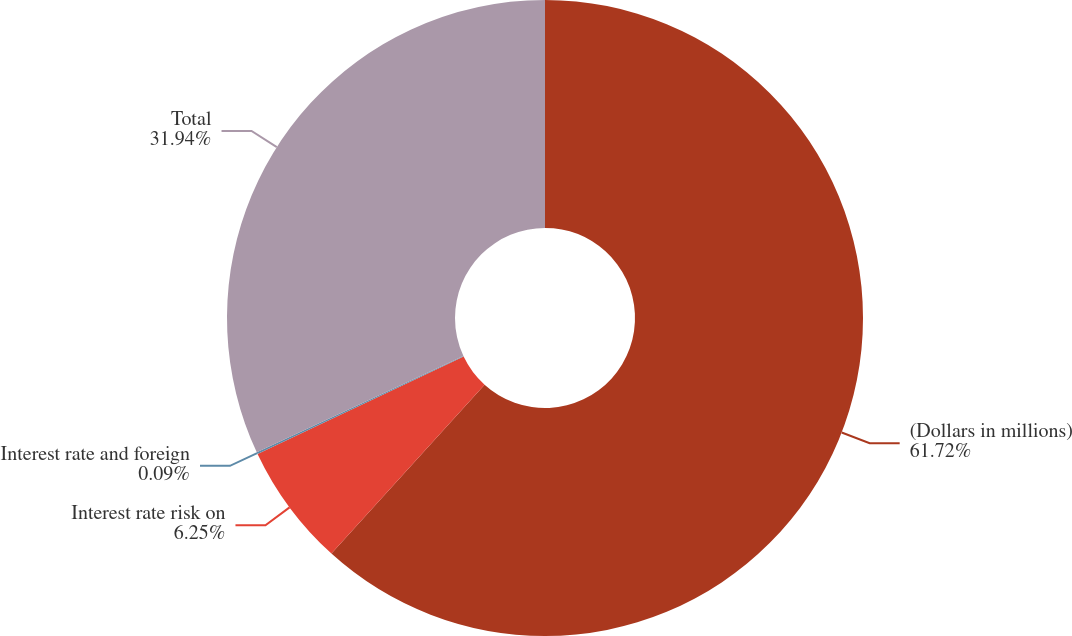Convert chart to OTSL. <chart><loc_0><loc_0><loc_500><loc_500><pie_chart><fcel>(Dollars in millions)<fcel>Interest rate risk on<fcel>Interest rate and foreign<fcel>Total<nl><fcel>61.72%<fcel>6.25%<fcel>0.09%<fcel>31.94%<nl></chart> 